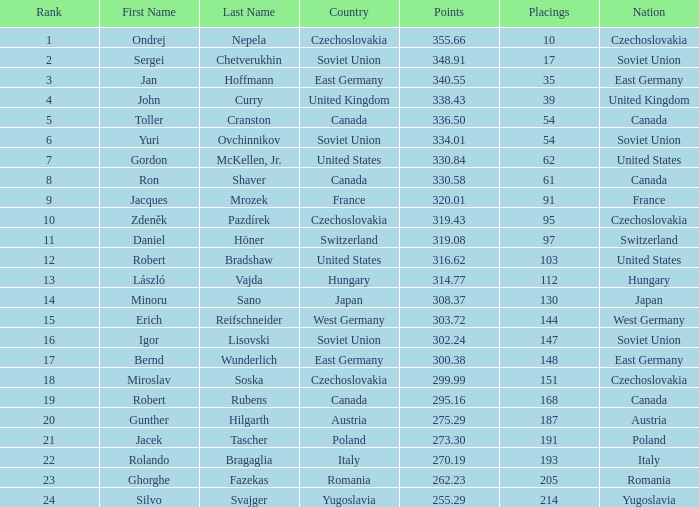Which rank holds a name of john curry and points surpassing 33 None. 